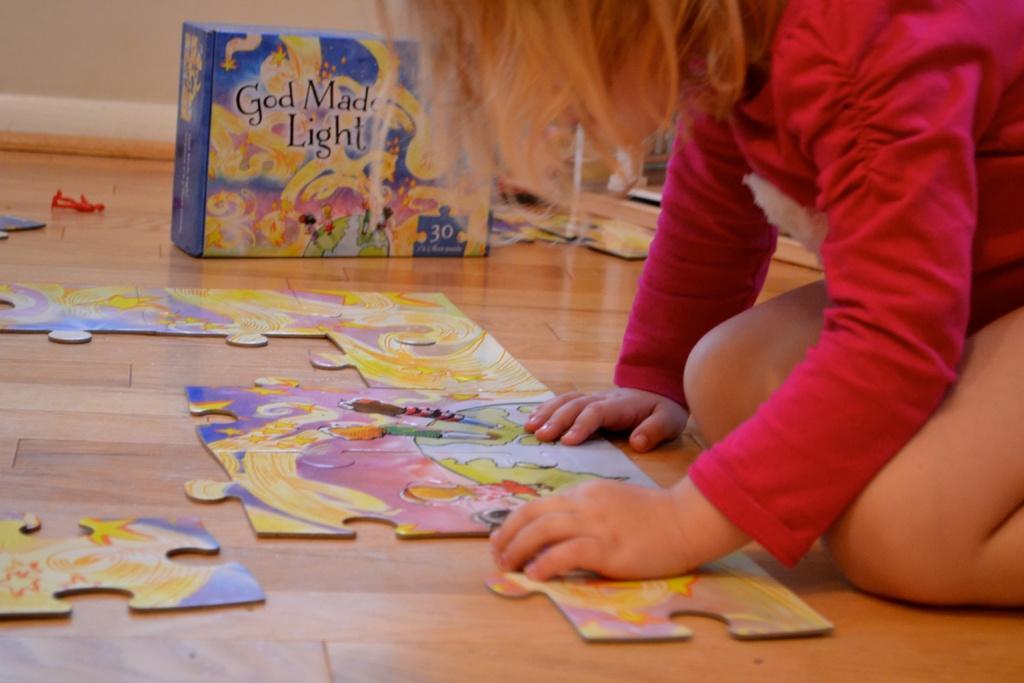Describe this image in one or two sentences. In this image there is a jigsaw puzzle on the wooden floor. To the right there is a kid sitting on the floor. Beside the kid there is a box. There are pictures and text on the box. Behind the box there is a wall. 